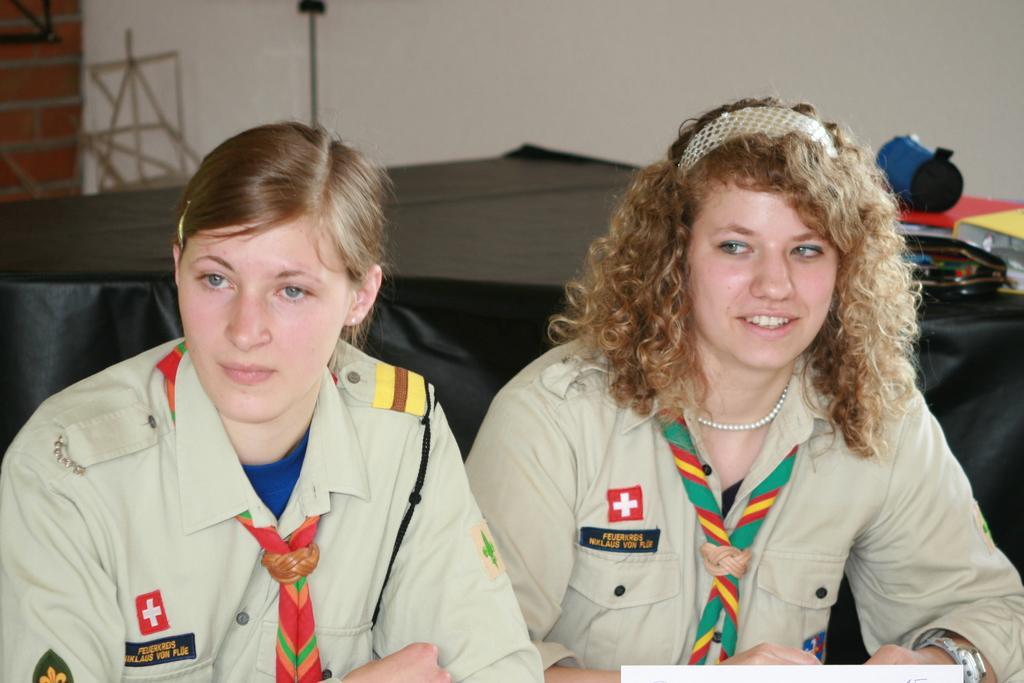Can you describe this image briefly? In this image there are two women sitting on chairs, in the background there is a table, on that table there are few items and there is a wall. 